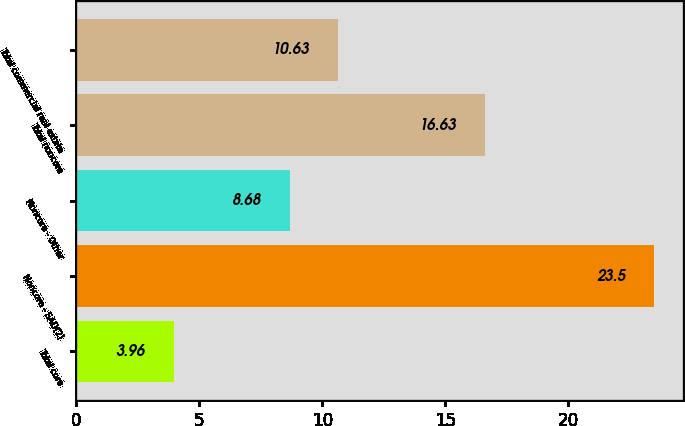<chart> <loc_0><loc_0><loc_500><loc_500><bar_chart><fcel>Total core<fcel>Noncore - SAD(2)<fcel>Noncore - Other<fcel>Total noncore<fcel>Total commercial real estate<nl><fcel>3.96<fcel>23.5<fcel>8.68<fcel>16.63<fcel>10.63<nl></chart> 